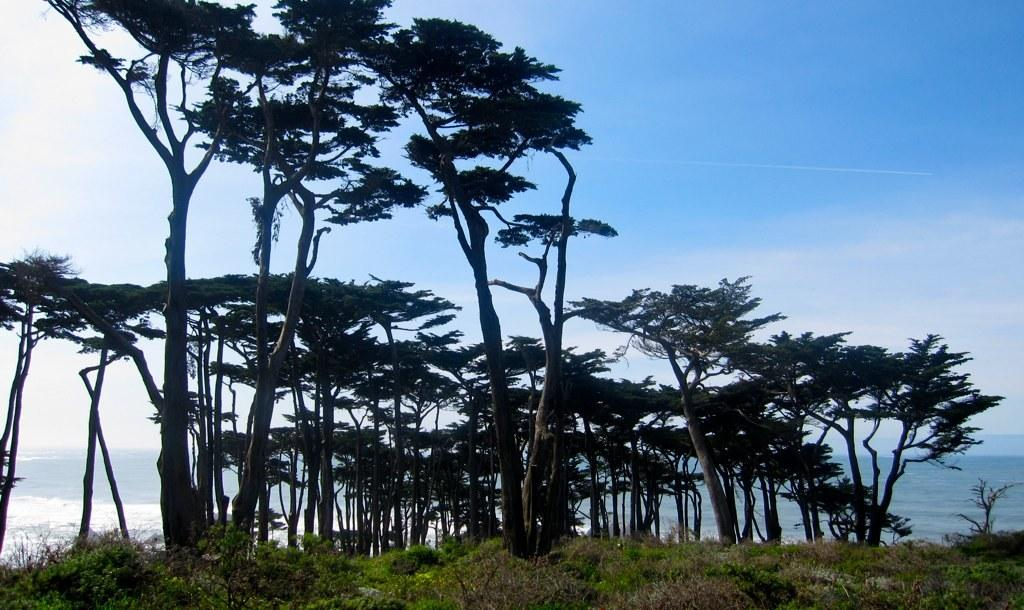What is the primary setting of the image? The picture is taken near a water source. What types of vegetation can be seen in the foreground of the image? There are plants, trees, and shrubs in the foreground of the image. What is visible in the background of the image? There is water visible in the background of the image. What is the weather like in the image? The sky is clear, and it is sunny in the image. What type of clam can be seen solving arithmetic problems in the image? There are no clams or arithmetic problems present in the image. Is there any indication of a birth or new life in the image? There is no indication of a birth or new life in the image. 